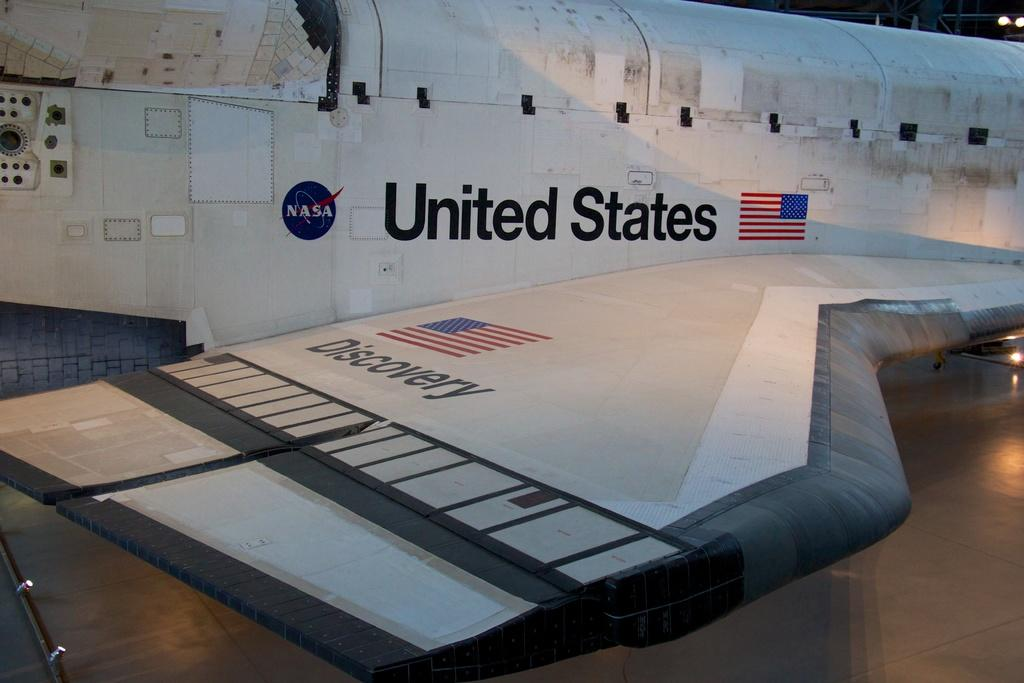<image>
Relay a brief, clear account of the picture shown. NASA is shown at the side of this space craft. 